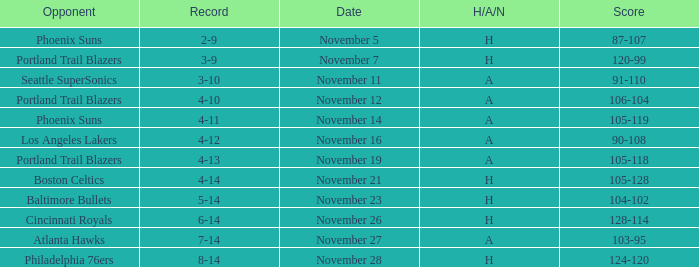On what Date was the Score 106-104 against the Portland Trail Blazers? November 12. 